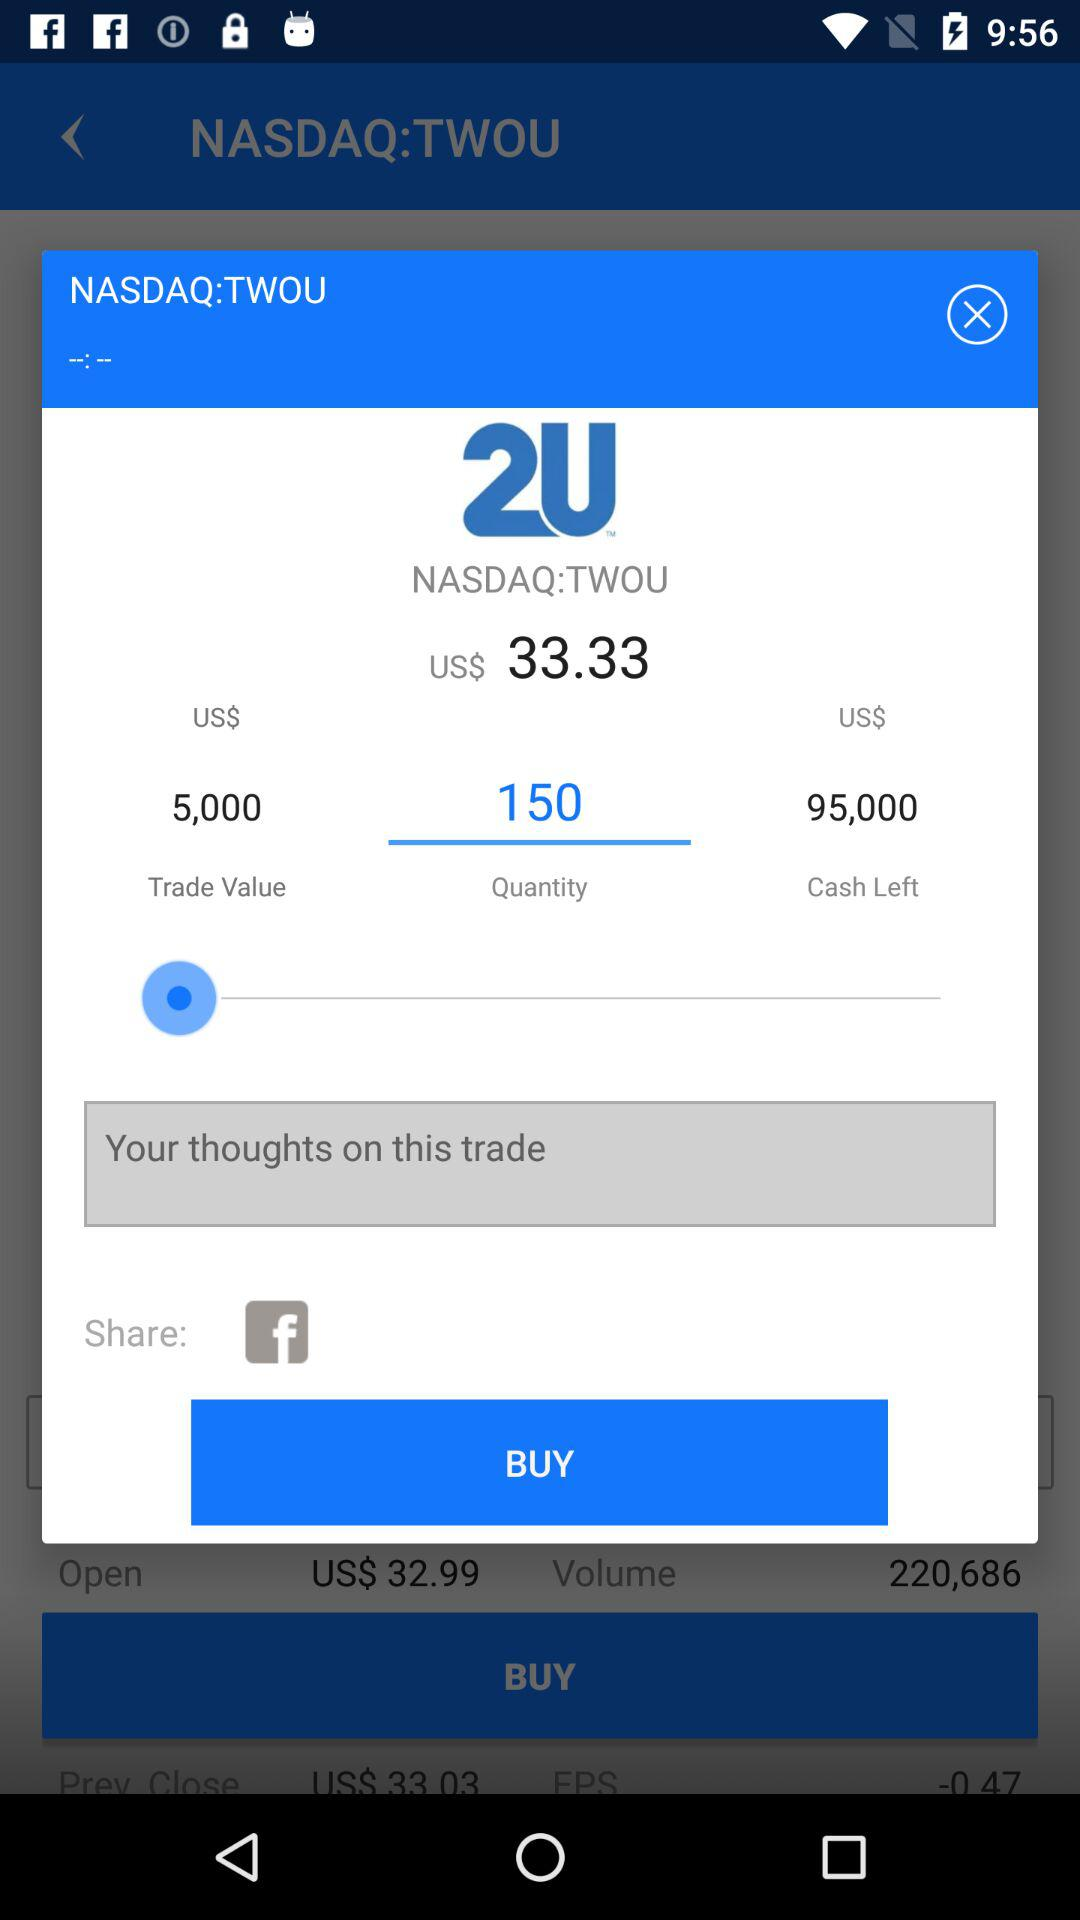What application is used to share? The application is Facebook. 